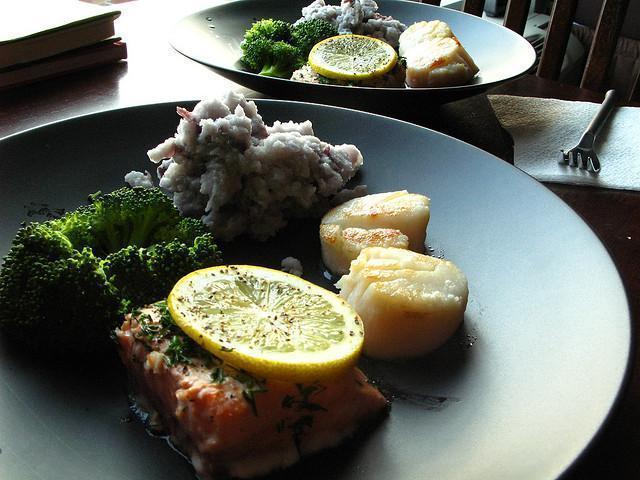Which food here is highest in vitamin B-12?
Indicate the correct choice and explain in the format: 'Answer: answer
Rationale: rationale.'
Options: Broccoli, salmon, potato, scallops. Answer: salmon.
Rationale: Salmon has b12. 